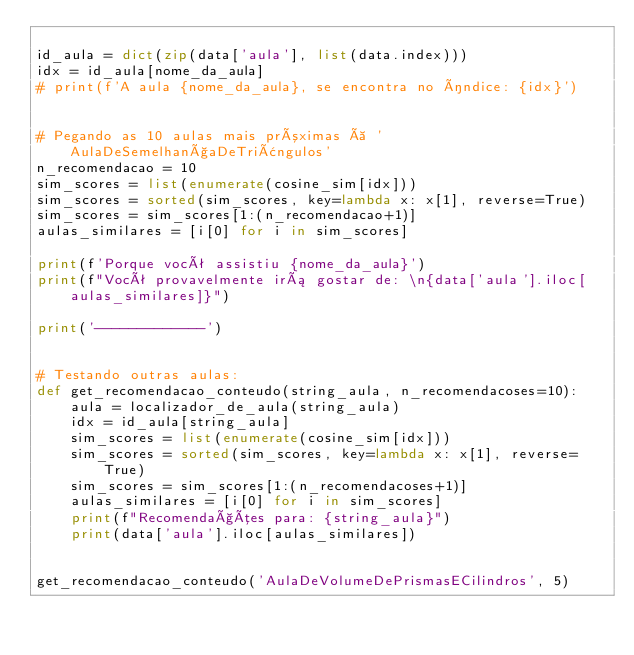Convert code to text. <code><loc_0><loc_0><loc_500><loc_500><_Python_>
id_aula = dict(zip(data['aula'], list(data.index)))
idx = id_aula[nome_da_aula]
# print(f'A aula {nome_da_aula}, se encontra no índice: {idx}')


# Pegando as 10 aulas mais próximas à 'AulaDeSemelhançaDeTriângulos'
n_recomendacao = 10
sim_scores = list(enumerate(cosine_sim[idx]))
sim_scores = sorted(sim_scores, key=lambda x: x[1], reverse=True)
sim_scores = sim_scores[1:(n_recomendacao+1)]
aulas_similares = [i[0] for i in sim_scores]

print(f'Porque você assistiu {nome_da_aula}')
print(f"Você provavelmente irá gostar de: \n{data['aula'].iloc[aulas_similares]}")

print('-------------')


# Testando outras aulas:
def get_recomendacao_conteudo(string_aula, n_recomendacoses=10):
    aula = localizador_de_aula(string_aula)
    idx = id_aula[string_aula]
    sim_scores = list(enumerate(cosine_sim[idx]))
    sim_scores = sorted(sim_scores, key=lambda x: x[1], reverse=True)
    sim_scores = sim_scores[1:(n_recomendacoses+1)]
    aulas_similares = [i[0] for i in sim_scores]
    print(f"Recomendações para: {string_aula}")
    print(data['aula'].iloc[aulas_similares])


get_recomendacao_conteudo('AulaDeVolumeDePrismasECilindros', 5)

</code> 